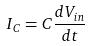Convert formula to latex. <formula><loc_0><loc_0><loc_500><loc_500>I _ { C } = C \frac { d V _ { i n } } { d t }</formula> 